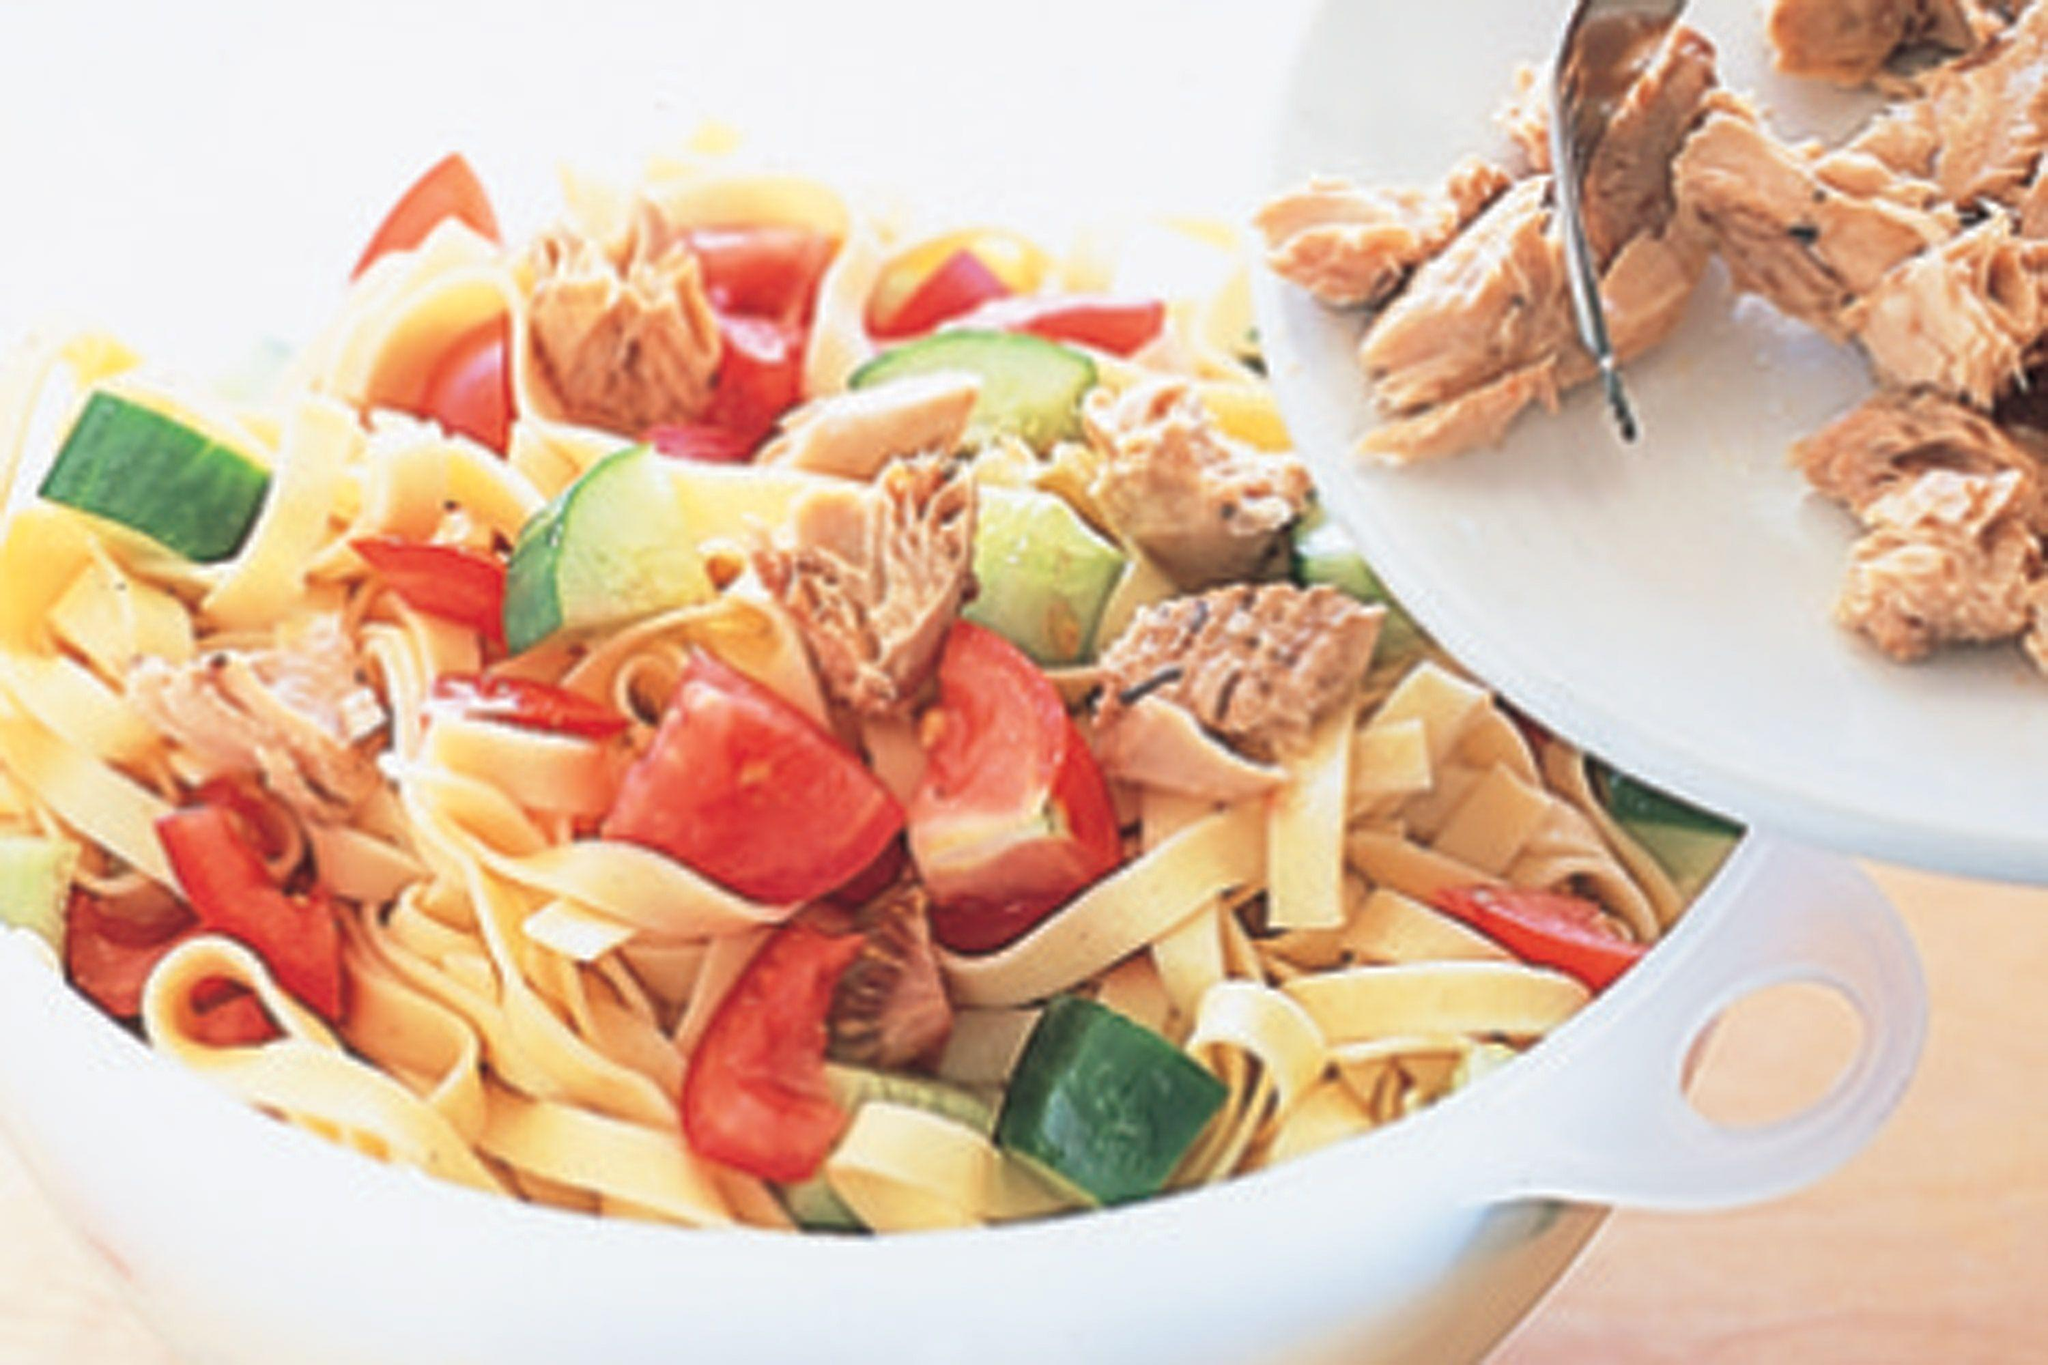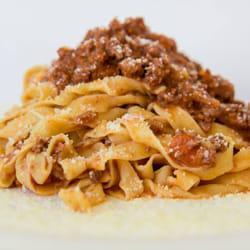The first image is the image on the left, the second image is the image on the right. Analyze the images presented: Is the assertion "One image includes a floured board and squarish pastries with mounded middles and scalloped edges, and the other image features noodles in a pile." valid? Answer yes or no. No. The first image is the image on the left, the second image is the image on the right. Assess this claim about the two images: "A cooking instrument is seen on the table in one of the images.". Correct or not? Answer yes or no. No. 